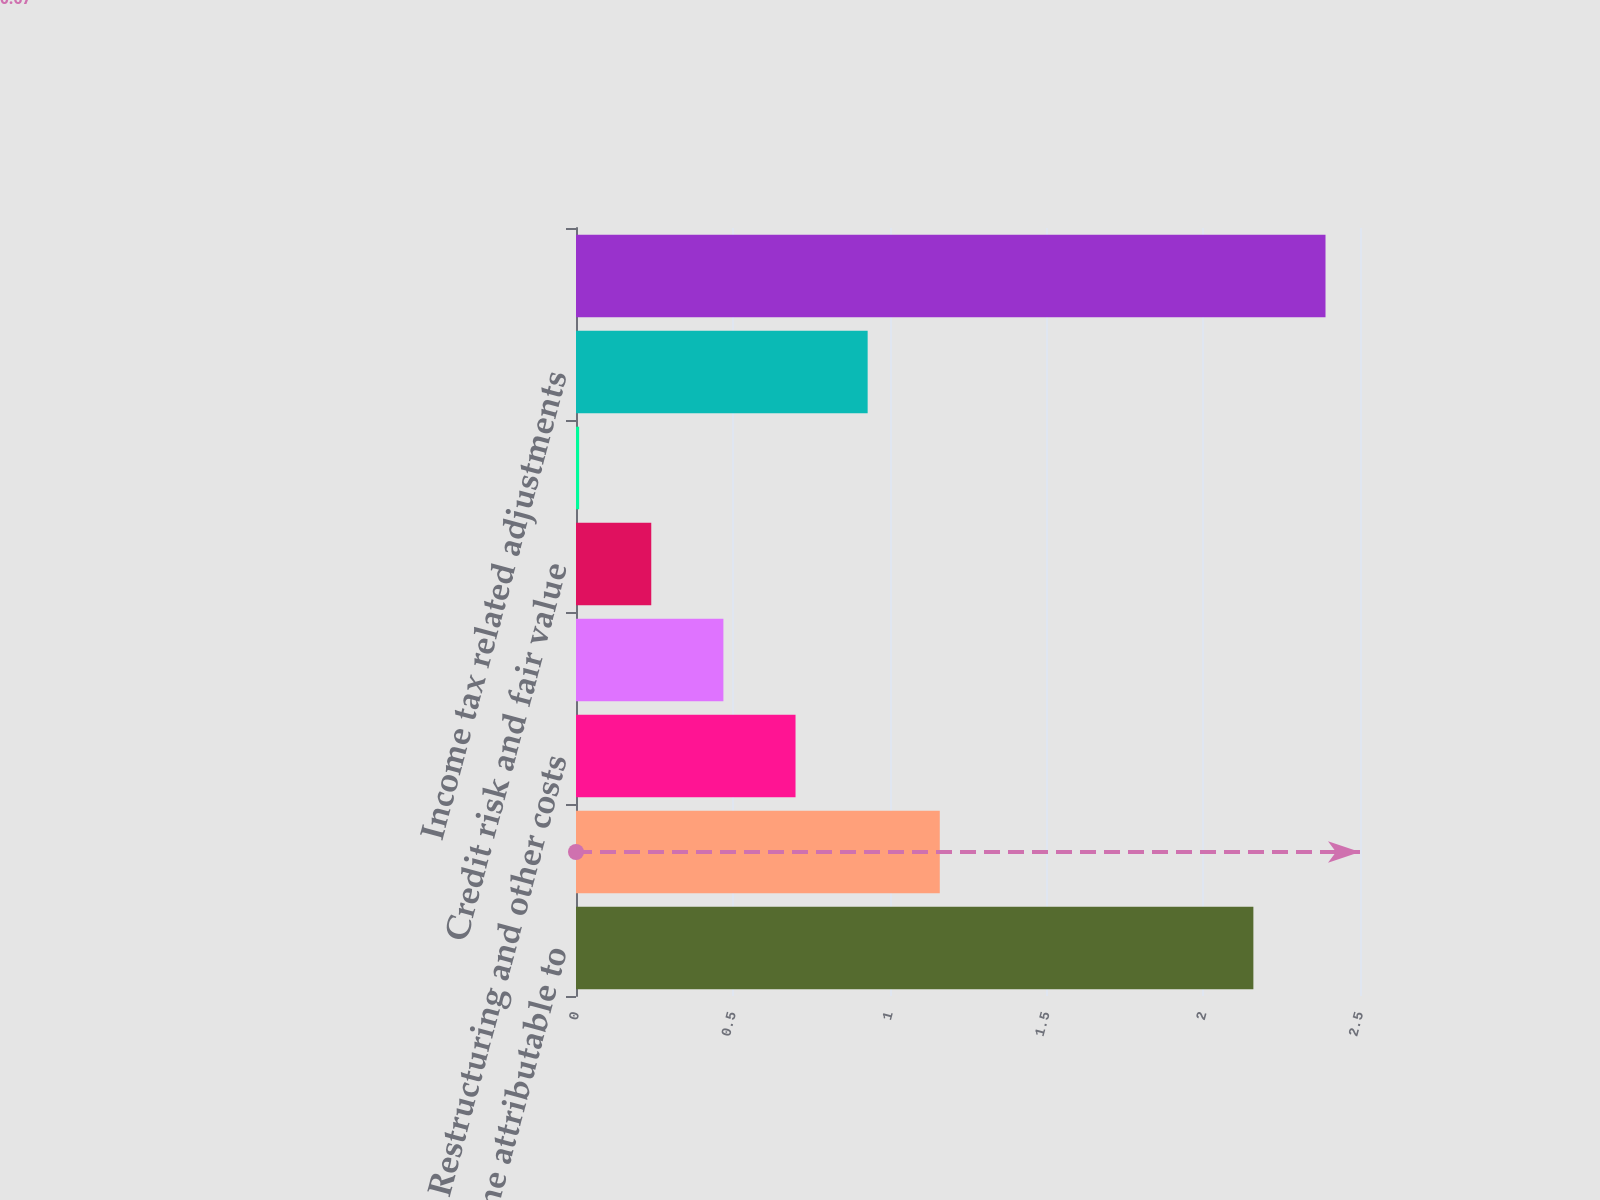Convert chart. <chart><loc_0><loc_0><loc_500><loc_500><bar_chart><fcel>Net income attributable to<fcel>Amortization of purchased<fcel>Restructuring and other costs<fcel>Acquisition related activities<fcel>Credit risk and fair value<fcel>Gain on fair value adjustment<fcel>Income tax related adjustments<fcel>Adjusted non-US GAAP earnings<nl><fcel>2.16<fcel>1.16<fcel>0.7<fcel>0.47<fcel>0.24<fcel>0.01<fcel>0.93<fcel>2.39<nl></chart> 